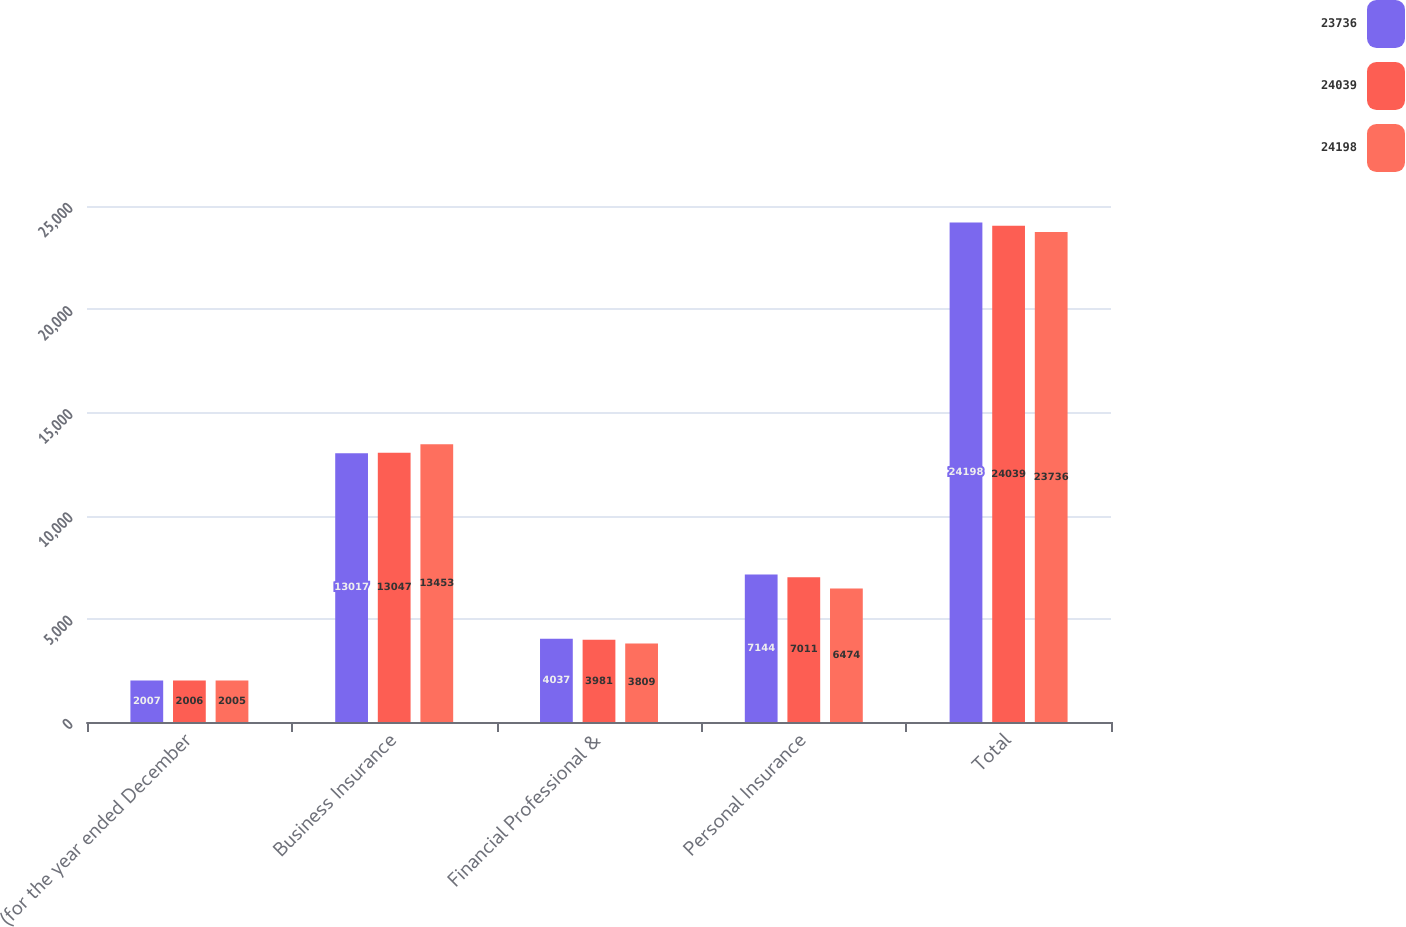Convert chart to OTSL. <chart><loc_0><loc_0><loc_500><loc_500><stacked_bar_chart><ecel><fcel>(for the year ended December<fcel>Business Insurance<fcel>Financial Professional &<fcel>Personal Insurance<fcel>Total<nl><fcel>23736<fcel>2007<fcel>13017<fcel>4037<fcel>7144<fcel>24198<nl><fcel>24039<fcel>2006<fcel>13047<fcel>3981<fcel>7011<fcel>24039<nl><fcel>24198<fcel>2005<fcel>13453<fcel>3809<fcel>6474<fcel>23736<nl></chart> 